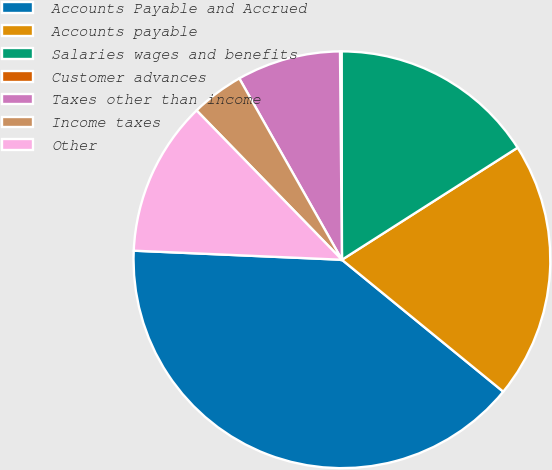<chart> <loc_0><loc_0><loc_500><loc_500><pie_chart><fcel>Accounts Payable and Accrued<fcel>Accounts payable<fcel>Salaries wages and benefits<fcel>Customer advances<fcel>Taxes other than income<fcel>Income taxes<fcel>Other<nl><fcel>39.79%<fcel>19.95%<fcel>15.99%<fcel>0.12%<fcel>8.05%<fcel>4.09%<fcel>12.02%<nl></chart> 